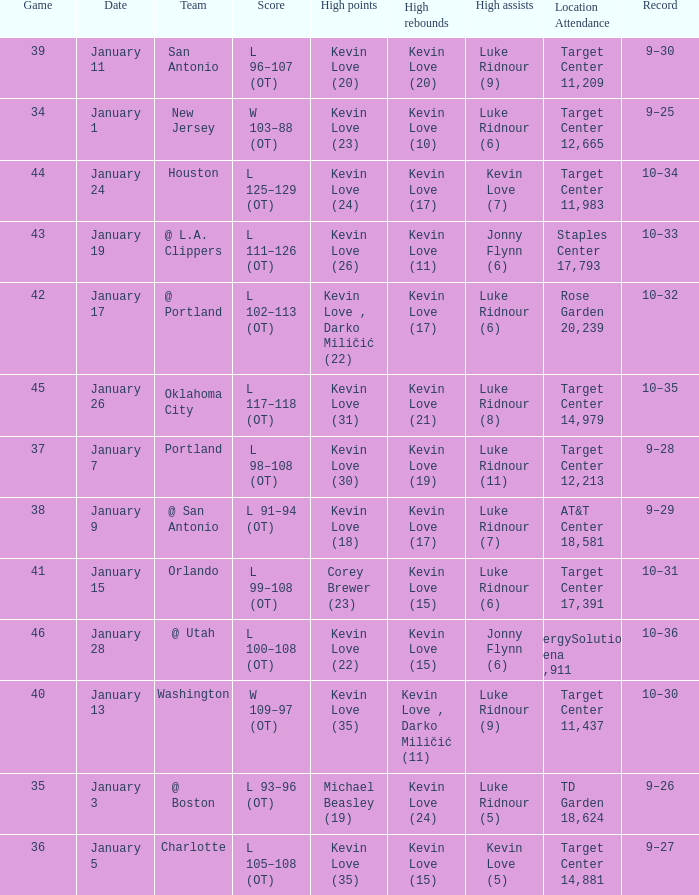When is the game involving team orlando scheduled? January 15. 